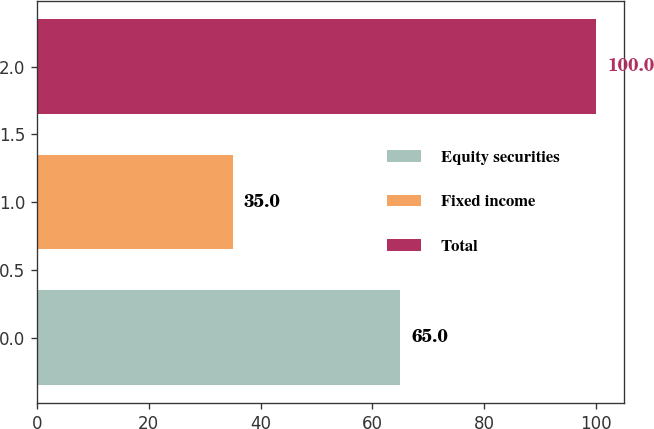Convert chart. <chart><loc_0><loc_0><loc_500><loc_500><bar_chart><fcel>Equity securities<fcel>Fixed income<fcel>Total<nl><fcel>65<fcel>35<fcel>100<nl></chart> 